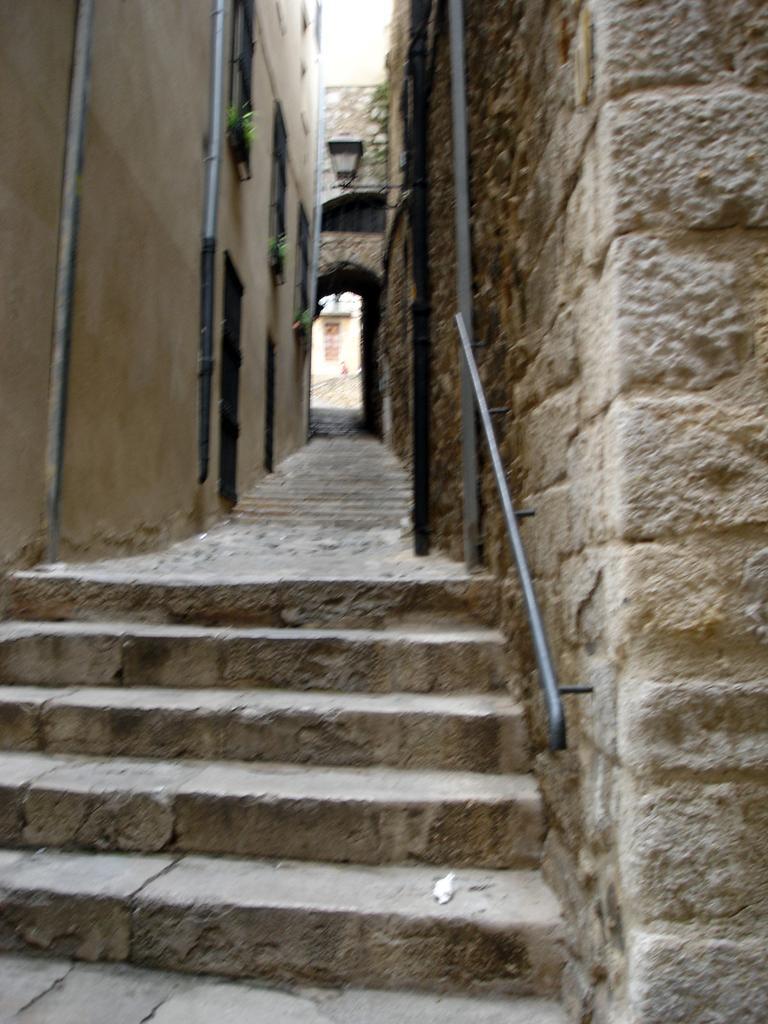Can you describe this image briefly? In this image, in the foreground there is a stair made up of stone and on the right side there are two poles and in the middle there is a narrow street. 